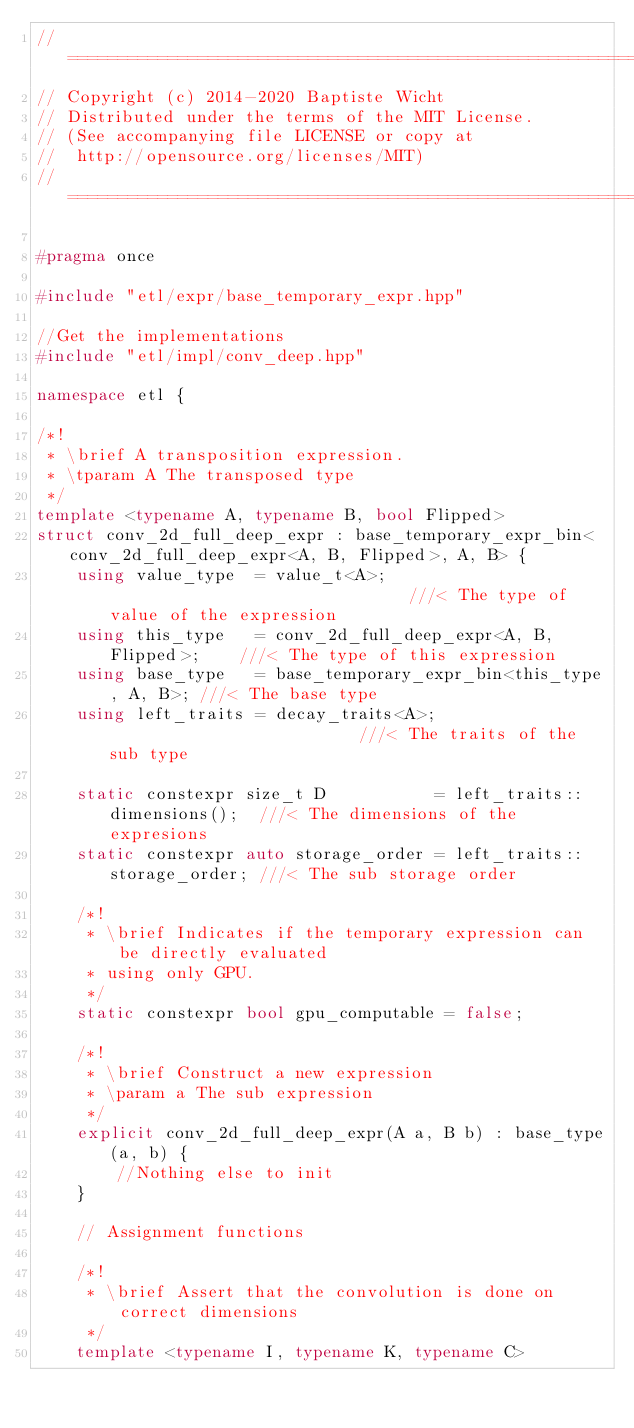<code> <loc_0><loc_0><loc_500><loc_500><_C++_>//=======================================================================
// Copyright (c) 2014-2020 Baptiste Wicht
// Distributed under the terms of the MIT License.
// (See accompanying file LICENSE or copy at
//  http://opensource.org/licenses/MIT)
//=======================================================================

#pragma once

#include "etl/expr/base_temporary_expr.hpp"

//Get the implementations
#include "etl/impl/conv_deep.hpp"

namespace etl {

/*!
 * \brief A transposition expression.
 * \tparam A The transposed type
 */
template <typename A, typename B, bool Flipped>
struct conv_2d_full_deep_expr : base_temporary_expr_bin<conv_2d_full_deep_expr<A, B, Flipped>, A, B> {
    using value_type  = value_t<A>;                               ///< The type of value of the expression
    using this_type   = conv_2d_full_deep_expr<A, B, Flipped>;    ///< The type of this expression
    using base_type   = base_temporary_expr_bin<this_type, A, B>; ///< The base type
    using left_traits = decay_traits<A>;                          ///< The traits of the sub type

    static constexpr size_t D           = left_traits::dimensions();  ///< The dimensions of the expresions
    static constexpr auto storage_order = left_traits::storage_order; ///< The sub storage order

    /*!
     * \brief Indicates if the temporary expression can be directly evaluated
     * using only GPU.
     */
    static constexpr bool gpu_computable = false;

    /*!
     * \brief Construct a new expression
     * \param a The sub expression
     */
    explicit conv_2d_full_deep_expr(A a, B b) : base_type(a, b) {
        //Nothing else to init
    }

    // Assignment functions

    /*!
     * \brief Assert that the convolution is done on correct dimensions
     */
    template <typename I, typename K, typename C></code> 